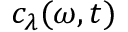<formula> <loc_0><loc_0><loc_500><loc_500>c _ { \lambda } ( \omega , t )</formula> 